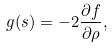<formula> <loc_0><loc_0><loc_500><loc_500>g ( s ) = - 2 \frac { \partial f } { \partial \rho } ,</formula> 